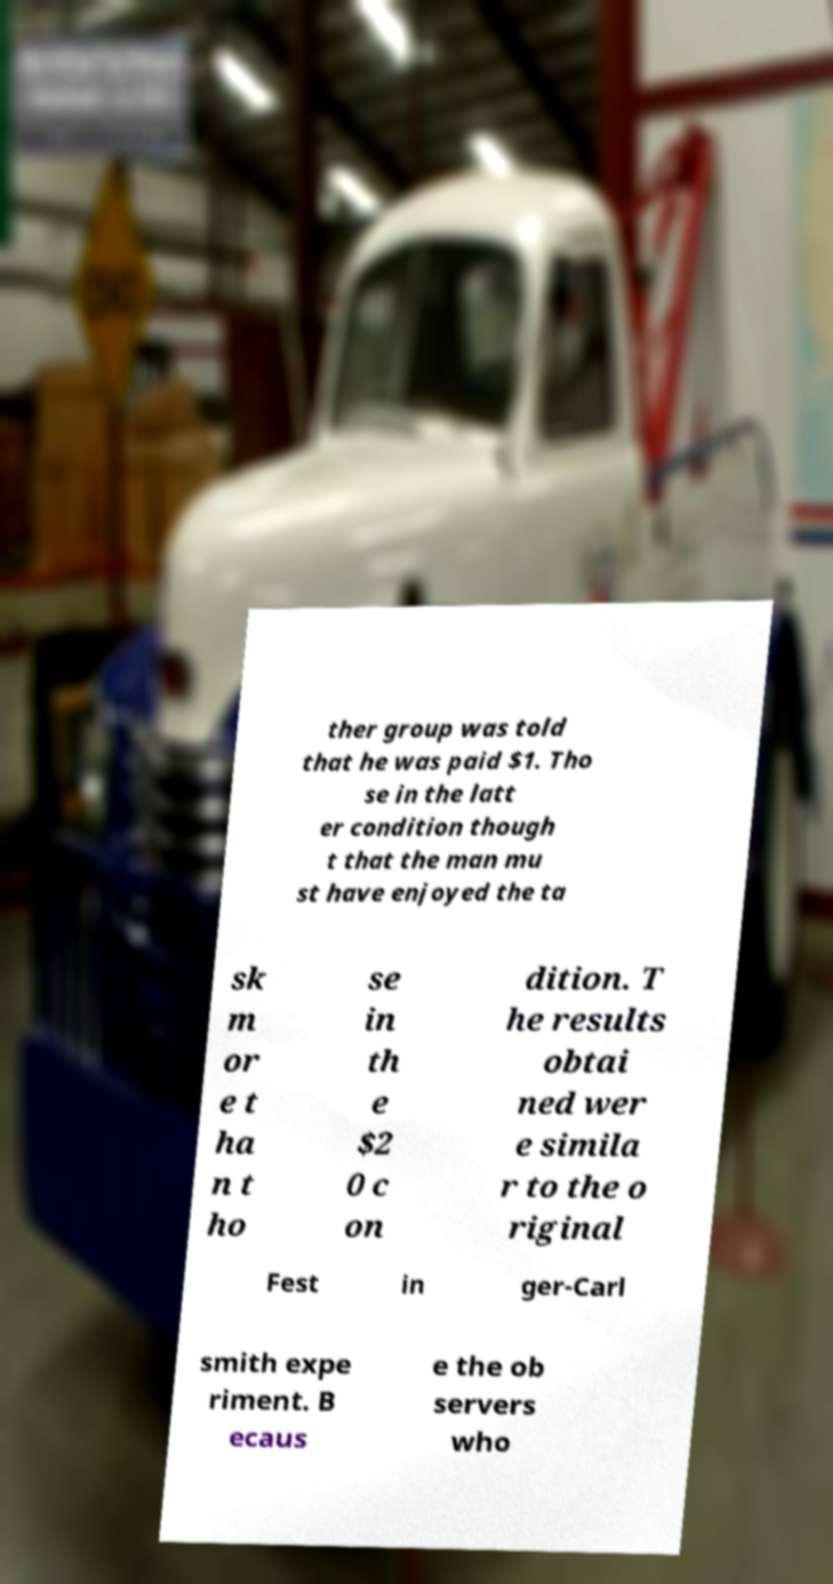Please read and relay the text visible in this image. What does it say? ther group was told that he was paid $1. Tho se in the latt er condition though t that the man mu st have enjoyed the ta sk m or e t ha n t ho se in th e $2 0 c on dition. T he results obtai ned wer e simila r to the o riginal Fest in ger-Carl smith expe riment. B ecaus e the ob servers who 